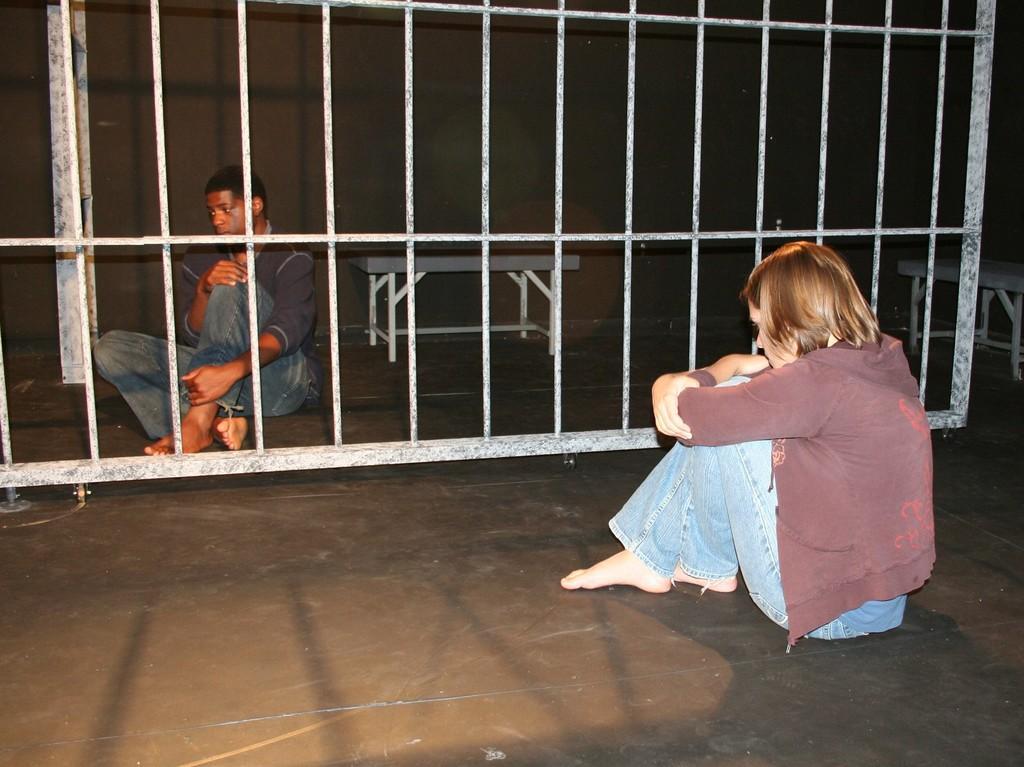Please provide a concise description of this image. This is the man and woman sitting on the floor. I think this is a gate with the wheels. These are the benches. Here is a wall, which is black in color. 